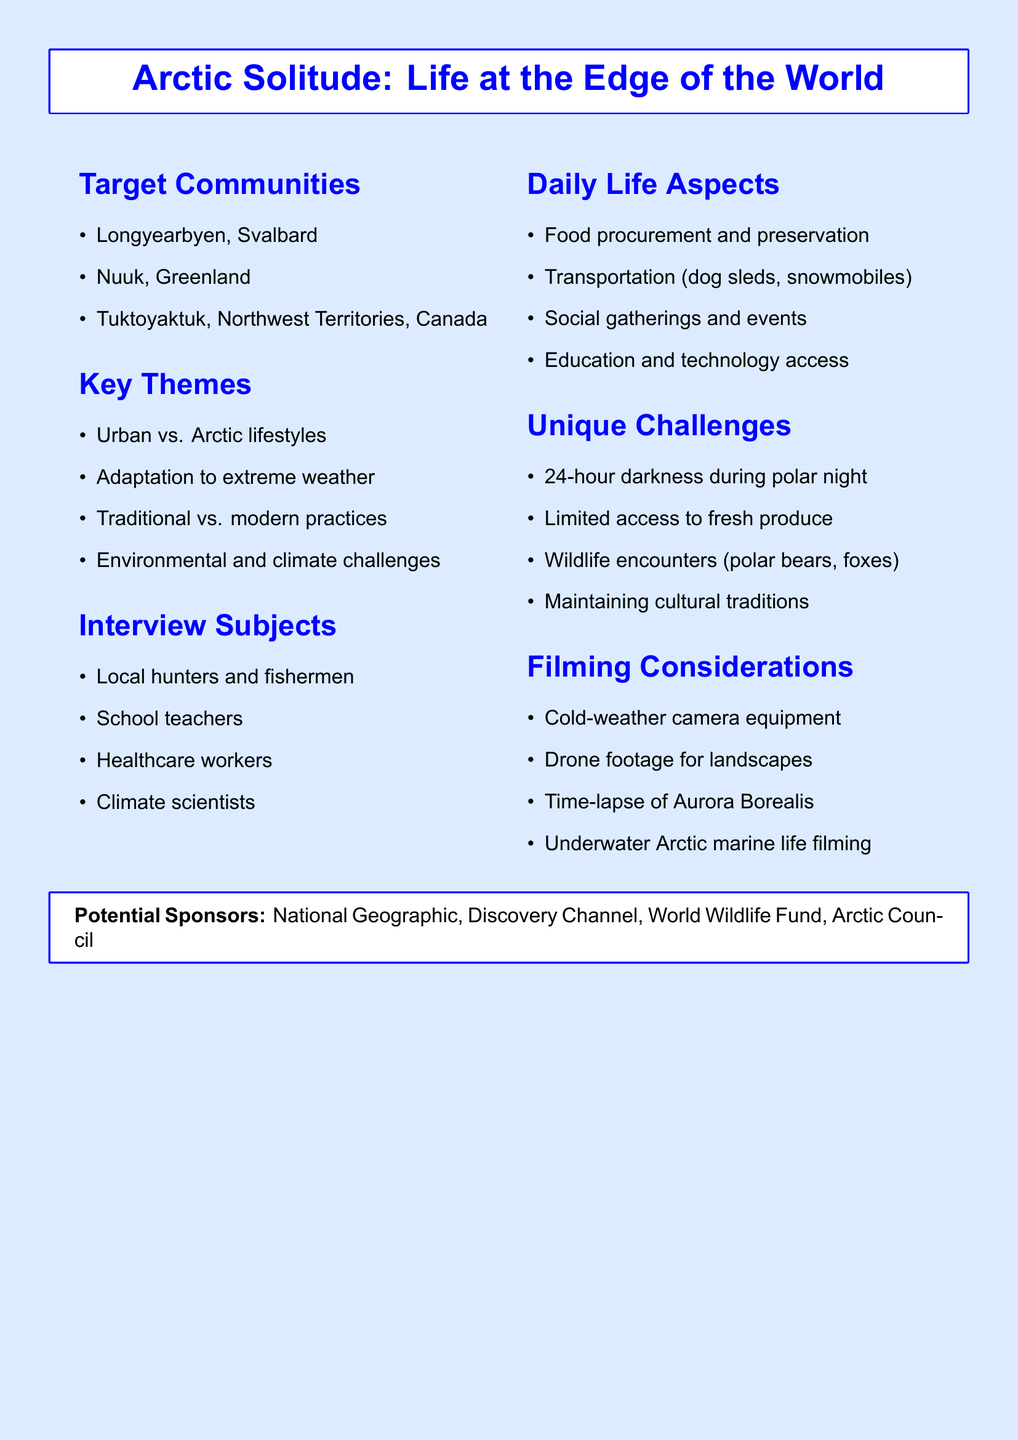What is the title of the documentary? The title of the documentary is stated in the document's header.
Answer: Arctic Solitude: Life at the Edge of the World How many target communities are mentioned? The document lists the target communities in a bulleted format.
Answer: Three What unique challenge is related to the polar night? The document specifies challenges faced in the Arctic during the polar night.
Answer: 24-hour darkness during polar night Which mode of transportation is mentioned for daily life? Transportation methods are listed in the section about daily life aspects.
Answer: Dog sleds, snowmobiles Who are the interview subjects for the documentary? The document outlines specific groups that will be interviewed.
Answer: Local hunters and fishermen, school teachers, healthcare workers, climate scientists What aspect of daily life involves community interaction? The document discusses various aspects of daily life, including social aspects.
Answer: Social gatherings and community events What filming consideration relates to weather conditions? The document includes filming considerations specific to the cold Arctic environment.
Answer: Cold-weather camera equipment Which organization is listed as a potential sponsor? The document lists various potential sponsors at the end.
Answer: National Geographic 